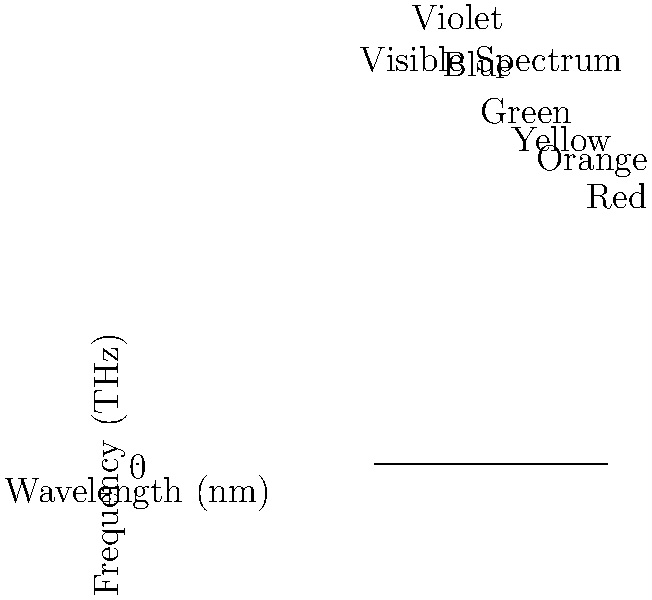In the world of television production, understanding color is crucial. The graph shows the relationship between wavelength and frequency for visible light. If a new high-definition TV screen uses blue light with a frequency of 640 THz, what is its approximate wavelength in nanometers? To solve this problem, we'll follow these steps:

1) Recall the relationship between frequency ($f$) and wavelength ($\lambda$):

   $c = f \lambda$

   Where $c$ is the speed of light (approximately $3 \times 10^8$ m/s)

2) We're given the frequency: $f = 640$ THz $= 640 \times 10^{12}$ Hz

3) Rearrange the equation to solve for wavelength:

   $\lambda = \frac{c}{f}$

4) Substitute the values:

   $\lambda = \frac{3 \times 10^8 \text{ m/s}}{640 \times 10^{12} \text{ Hz}}$

5) Simplify:

   $\lambda = \frac{3 \times 10^8}{640 \times 10^{12}} \text{ m} = 4.6875 \times 10^{-7} \text{ m}$

6) Convert to nanometers:

   $4.6875 \times 10^{-7} \text{ m} = 468.75 \text{ nm}$

7) Looking at the graph, we can see this corresponds to the blue region of the visible spectrum.
Answer: $\approx 469$ nm 